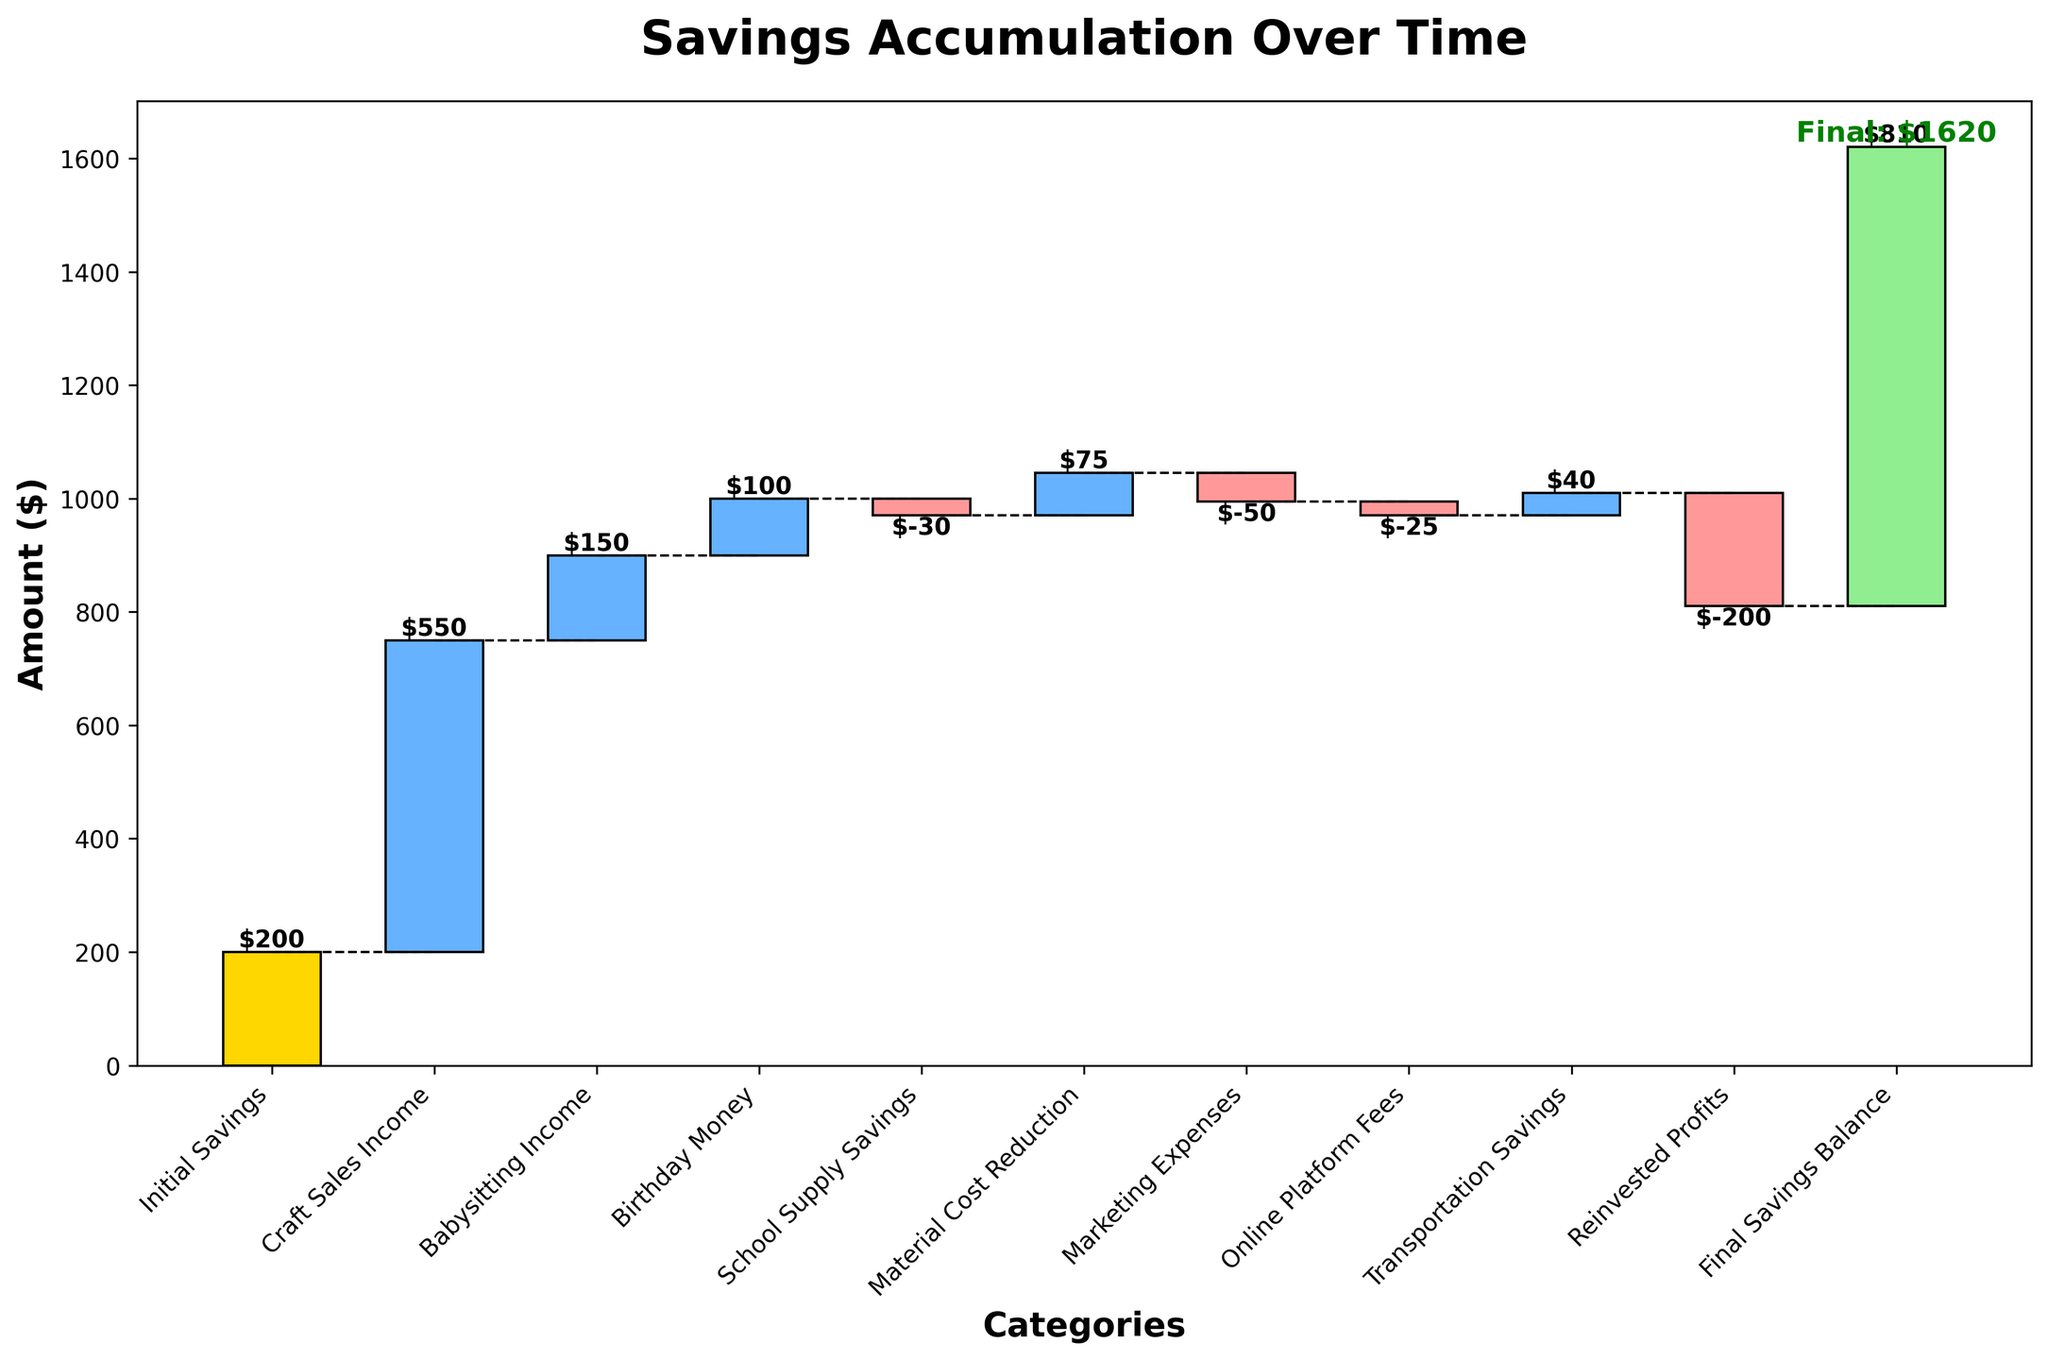What is the title of the chart? The title of the chart is displayed at the top of the figure and reads 'Savings Accumulation Over Time'.
Answer: Savings Accumulation Over Time Which category contributes the most to the savings? By observing the tallest bar in the waterfall chart that contributes positively, we identify 'Craft Sales Income' as the category with the largest positive contribution.
Answer: Craft Sales Income What is the final savings balance? The final bar on the right side of the chart shows the final accumulated value, labeled as 'Final: $810'.
Answer: $810 How much did material cost reduction save? The bar labeled 'Material Cost Reduction' has a value indicated on top of the bar. This value is $75.
Answer: $75 What is the total contribution from income sources? The income sources are 'Craft Sales Income', 'Babysitting Income', and 'Birthday Money'. Adding them up: 550 + 150 + 100 = 800.
Answer: $800 Which expense had the largest negative impact on savings? Among the negative values, we identify the largest bar in the downward direction. 'Reinvested Profits' with -200 had the largest negative impact.
Answer: Reinvested Profits What is the net effect of all expense reductions? Expense reductions include 'Material Cost Reduction' and 'Transportation Savings'. Summing them yields 75 + 40 = 115.
Answer: $115 How does the final savings balance compare to the initial savings? The initial savings started at $200, and the final savings balance is $810. The increase is 810 - 200 = 610.
Answer: $610 increase What is the net effect of all expenses? Summing the negative contributions: -30 (School Supply Savings) + -50 (Marketing Expenses) + -25 (Online Platform Fees) + -200 (Reinvested Profits) = -305.
Answer: -$305 What is the greatest visual difference between any two consecutive categories? Checking differences between consecutive categories, the largest difference lies between 'Babysitting Income' (150) and 'Birthday Money' (100), making the difference 150 - 100 = 50.
Answer: $50 